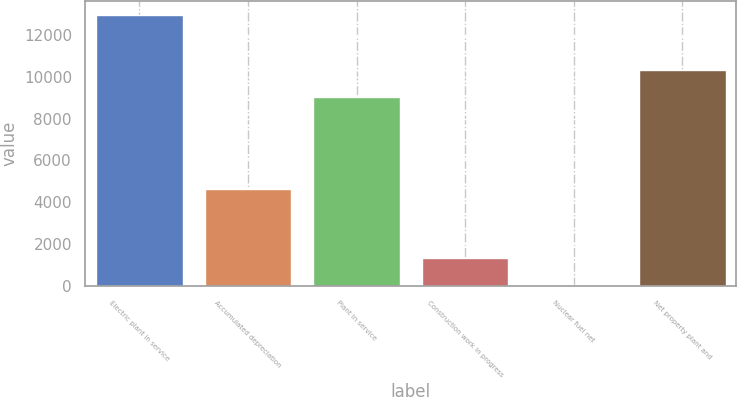<chart> <loc_0><loc_0><loc_500><loc_500><bar_chart><fcel>Electric plant in service<fcel>Accumulated depreciation<fcel>Plant in service<fcel>Construction work in progress<fcel>Nuclear fuel net<fcel>Net property plant and<nl><fcel>12954.3<fcel>4651.7<fcel>9041.6<fcel>1359.69<fcel>71.4<fcel>10329.9<nl></chart> 